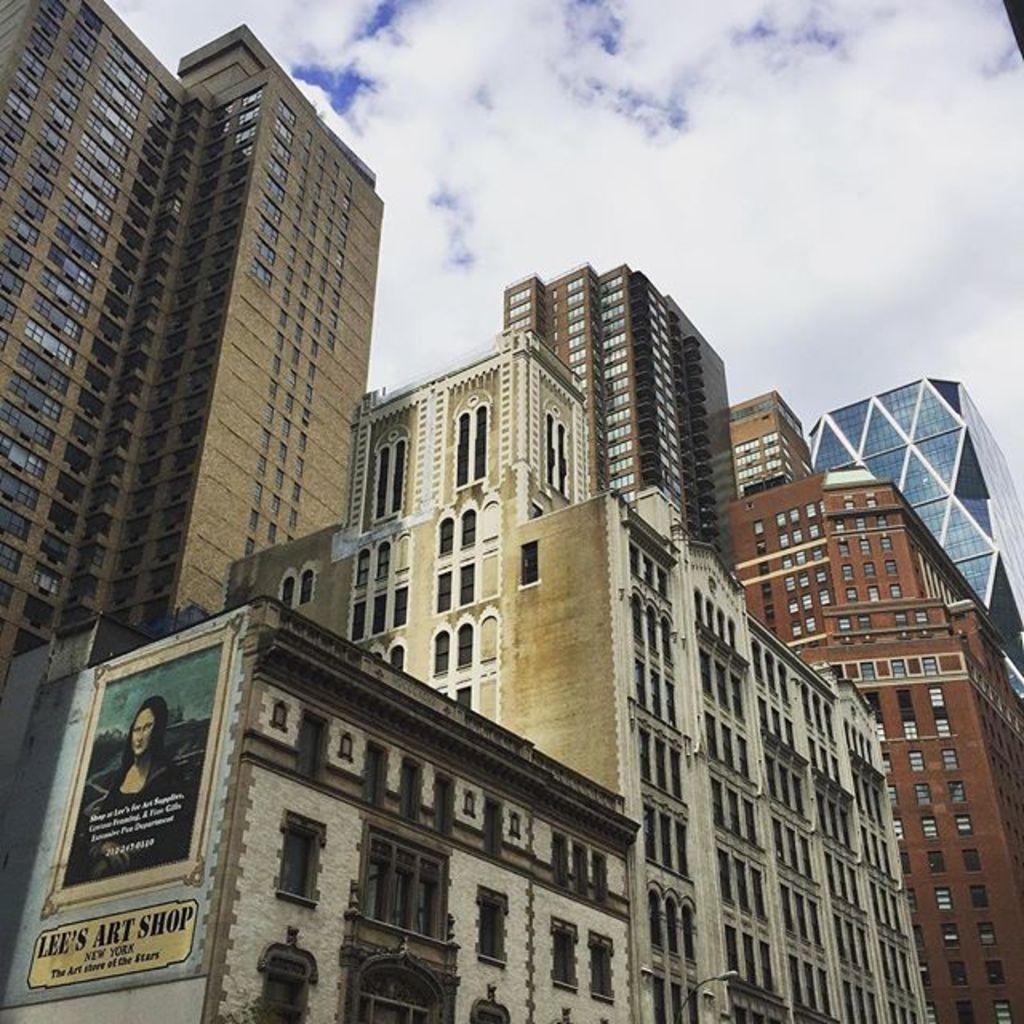In one or two sentences, can you explain what this image depicts? In this image we can see so many big buildings, one board with some text and picture attached to one building. At the top there is the sky. 